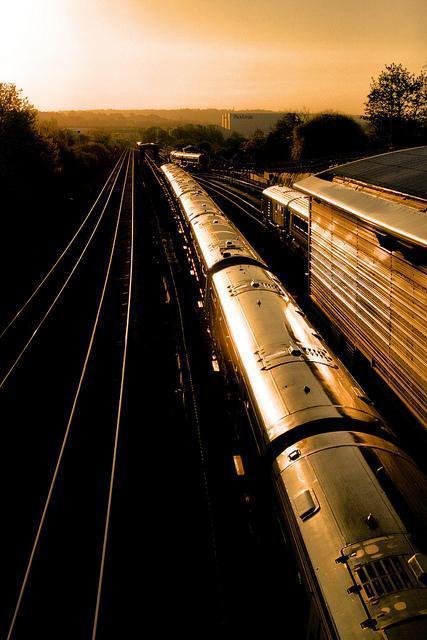How many trains are visible?
Give a very brief answer. 3. How many trains are in the picture?
Give a very brief answer. 2. 